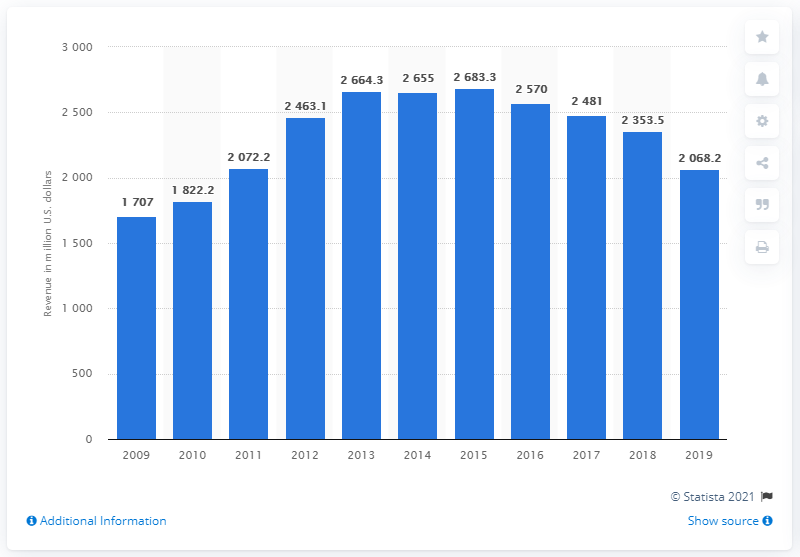Outline some significant characteristics in this image. In 2010, GNC generated approximately 1822.2 million in revenue. 